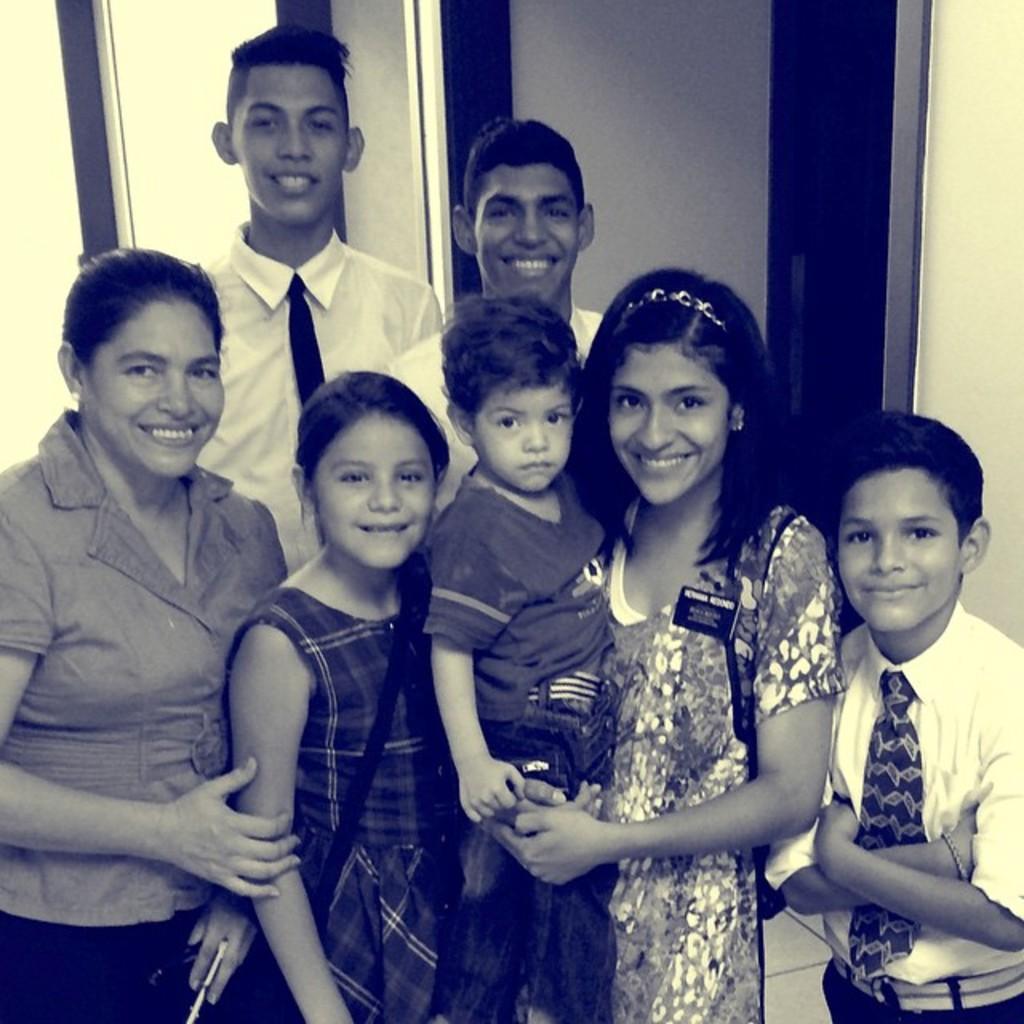In one or two sentences, can you explain what this image depicts? In this image I can see few people. Except one I can see smile on their faces. 